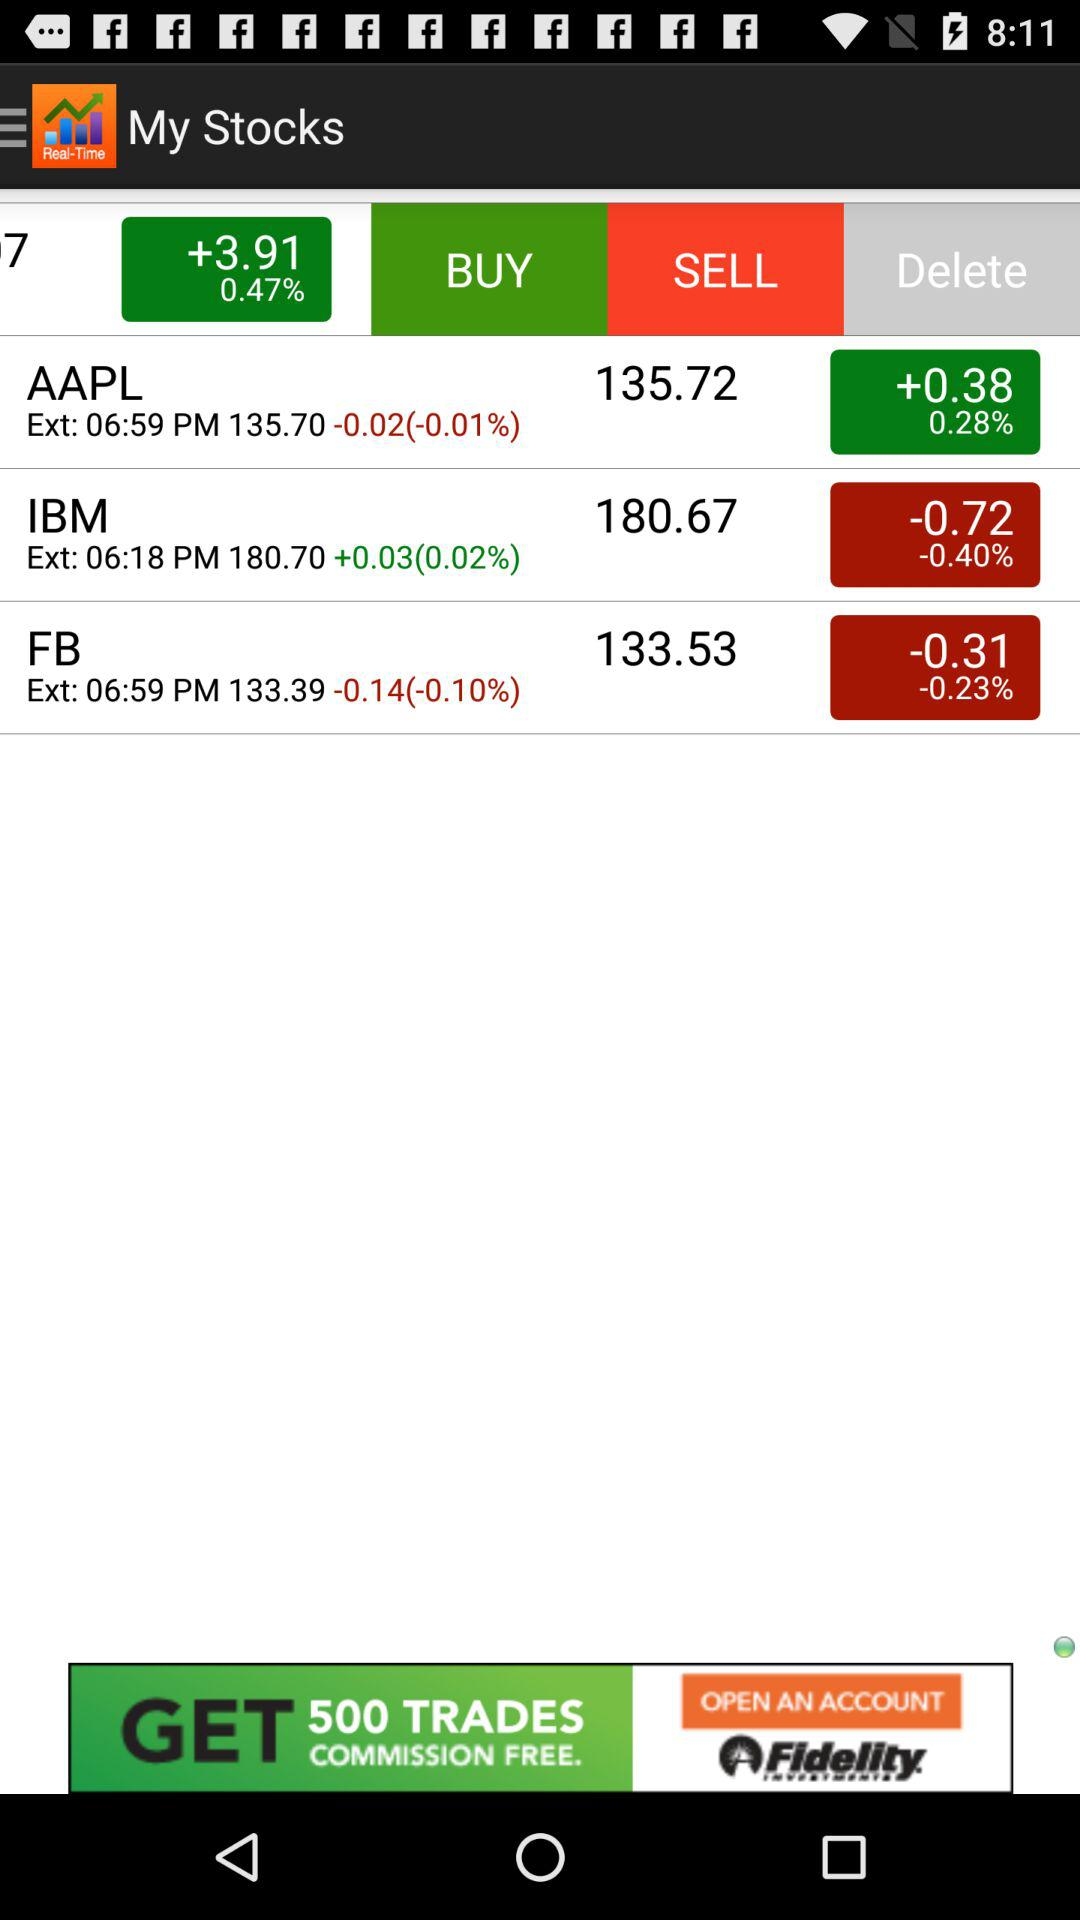What is the current price of AAPL? The current price of AAPL is 135.72. 